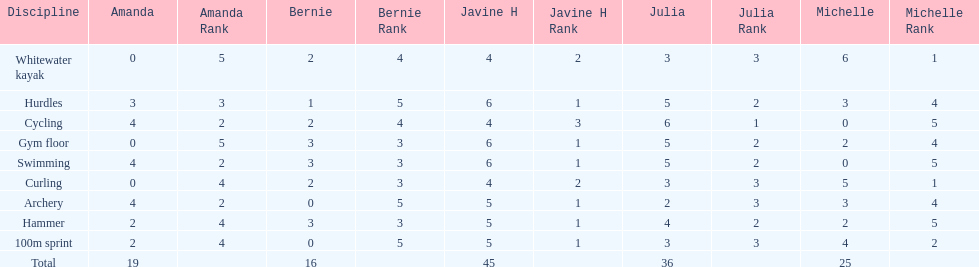Which of the girls had the least amount in archery? Bernie. 